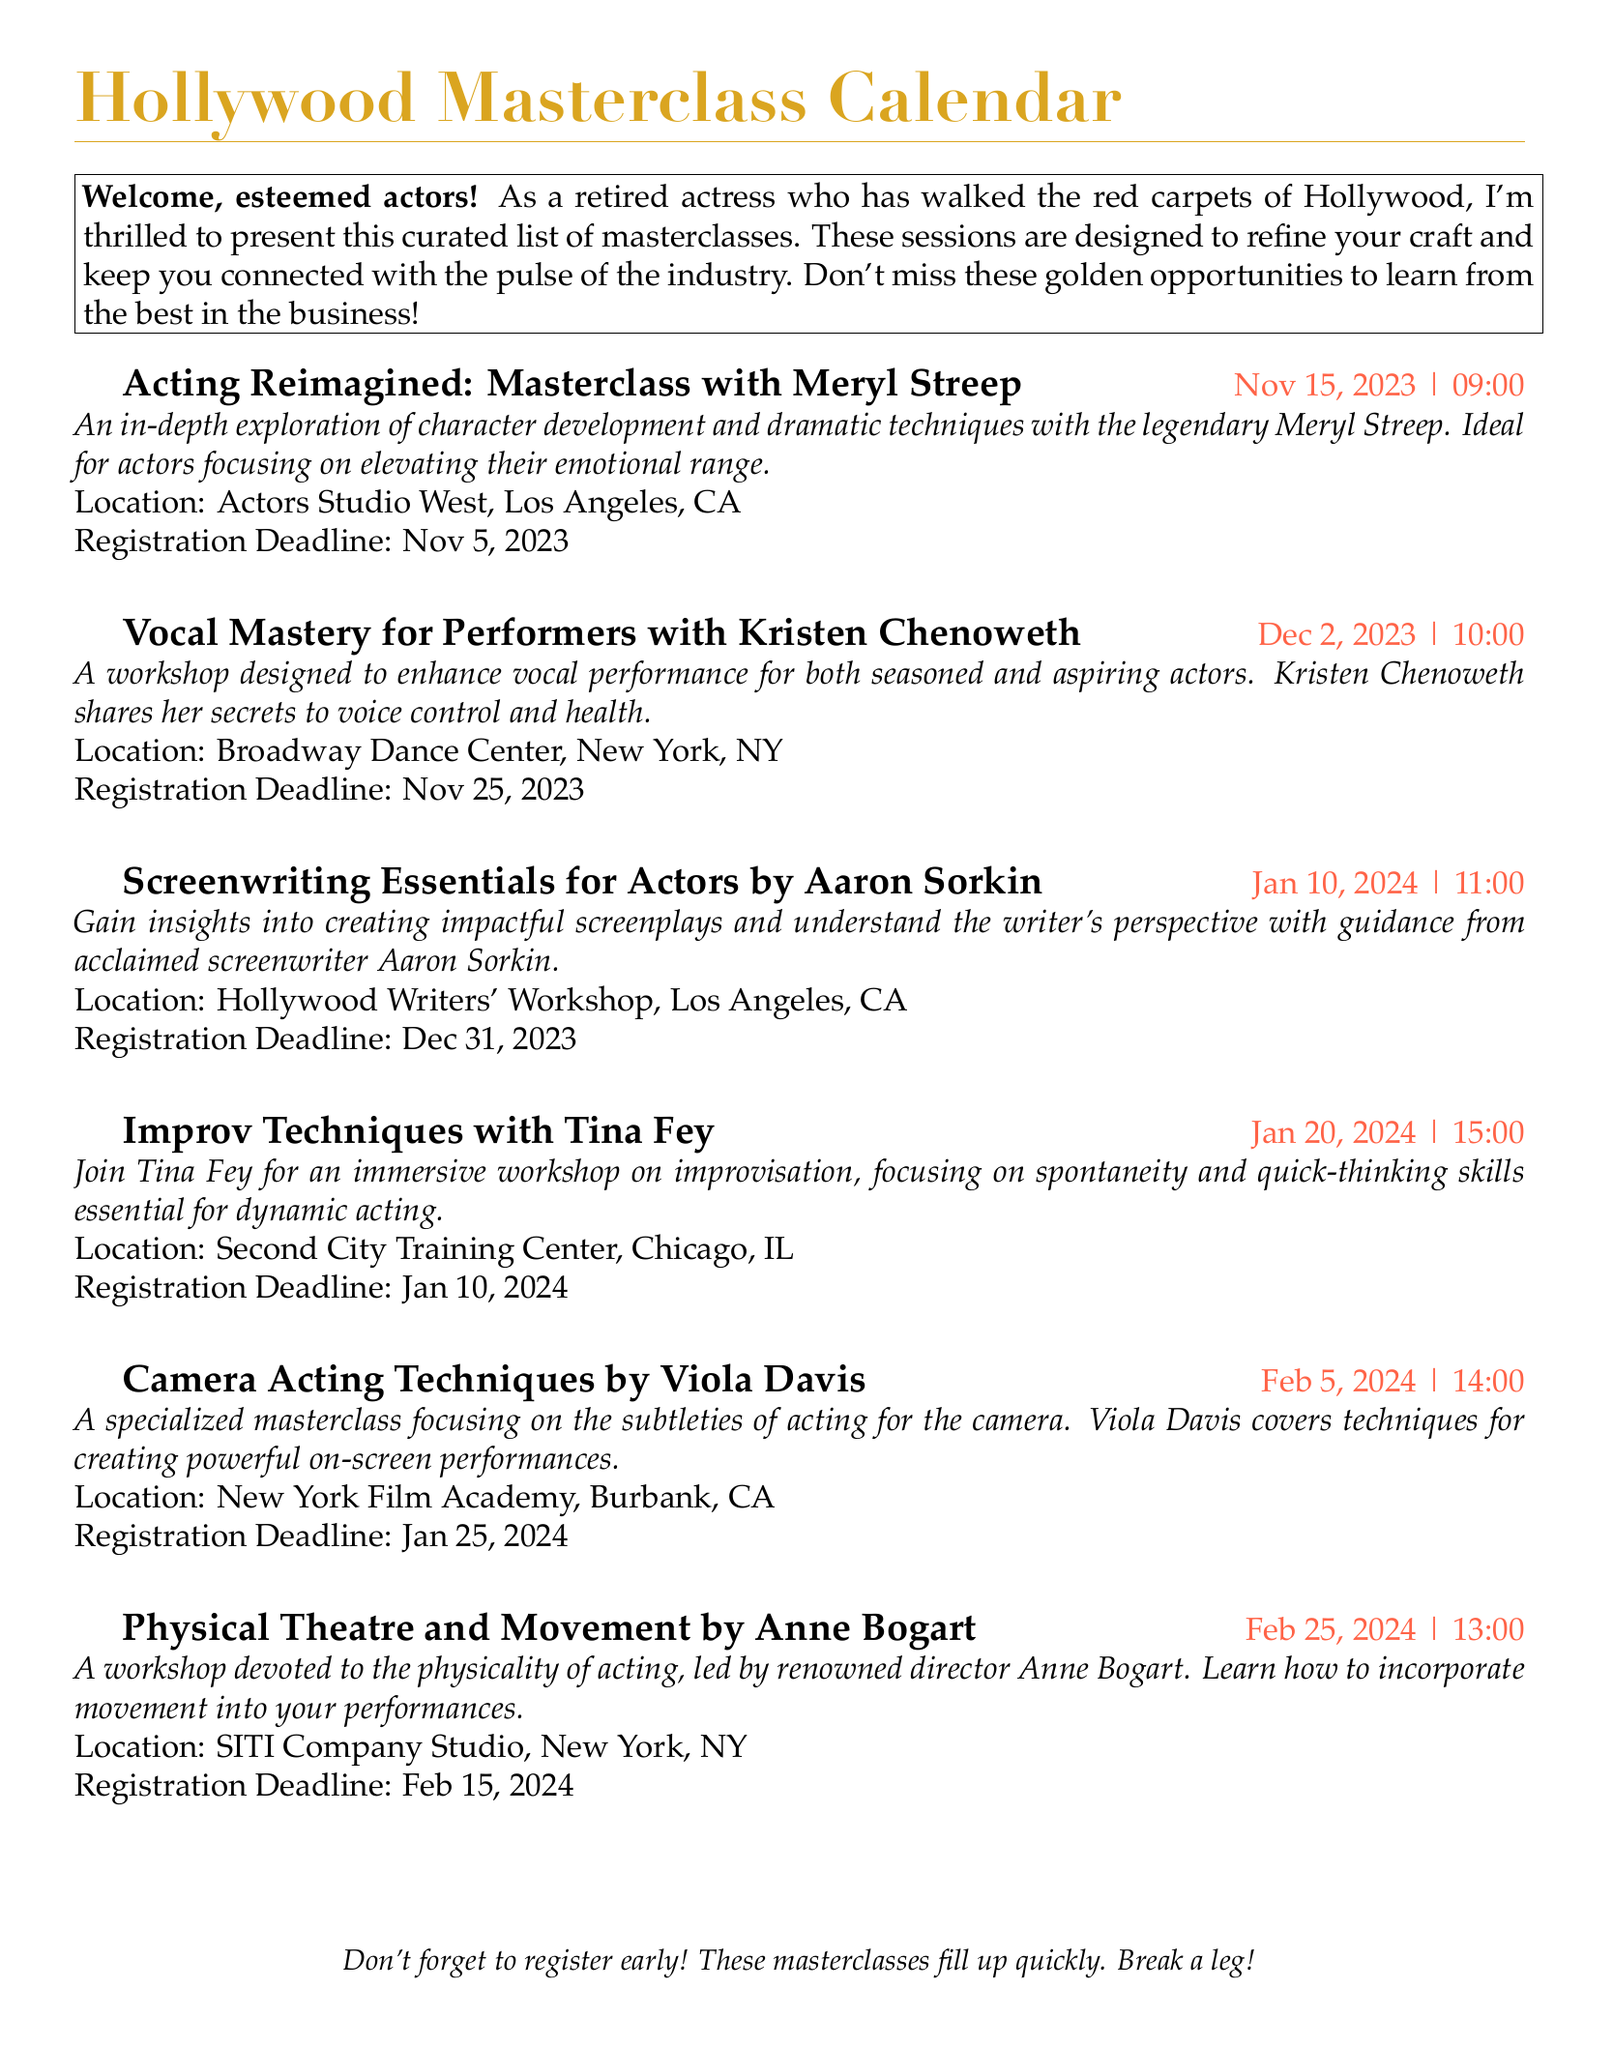What is the title of the first masterclass? The first masterclass listed in the document is titled "Acting Reimagined: Masterclass with Meryl Streep".
Answer: Acting Reimagined: Masterclass with Meryl Streep When is the registration deadline for the Vocal Mastery for Performers workshop? The registration deadline for the workshop is specified in the document as November 25, 2023.
Answer: Nov 25, 2023 Who is leading the Improv Techniques workshop? The document states that Tina Fey is leading the Improv Techniques workshop.
Answer: Tina Fey What is the location of the Camera Acting Techniques masterclass? The document indicates that the location for the Camera Acting Techniques masterclass is New York Film Academy, Burbank, CA.
Answer: New York Film Academy, Burbank, CA How many days are there between the deadline for the Acting Reimagined masterclass and its date? The document states the masterclass is on November 15, 2023 and the deadline is November 5, 2023, which is a difference of 10 days.
Answer: 10 days Which masterclass focuses on vocal performance? According to the document, the masterclass focusing on vocal performance is "Vocal Mastery for Performers with Kristen Chenoweth".
Answer: Vocal Mastery for Performers with Kristen Chenoweth What unique skill is emphasized in the Physical Theatre and Movement workshop? The document highlights that the workshop emphasizes the physicality of acting.
Answer: Physicality of acting How many masterclasses are scheduled for January 2024? The document lists two masterclasses scheduled for January 2024.
Answer: 2 masterclasses 